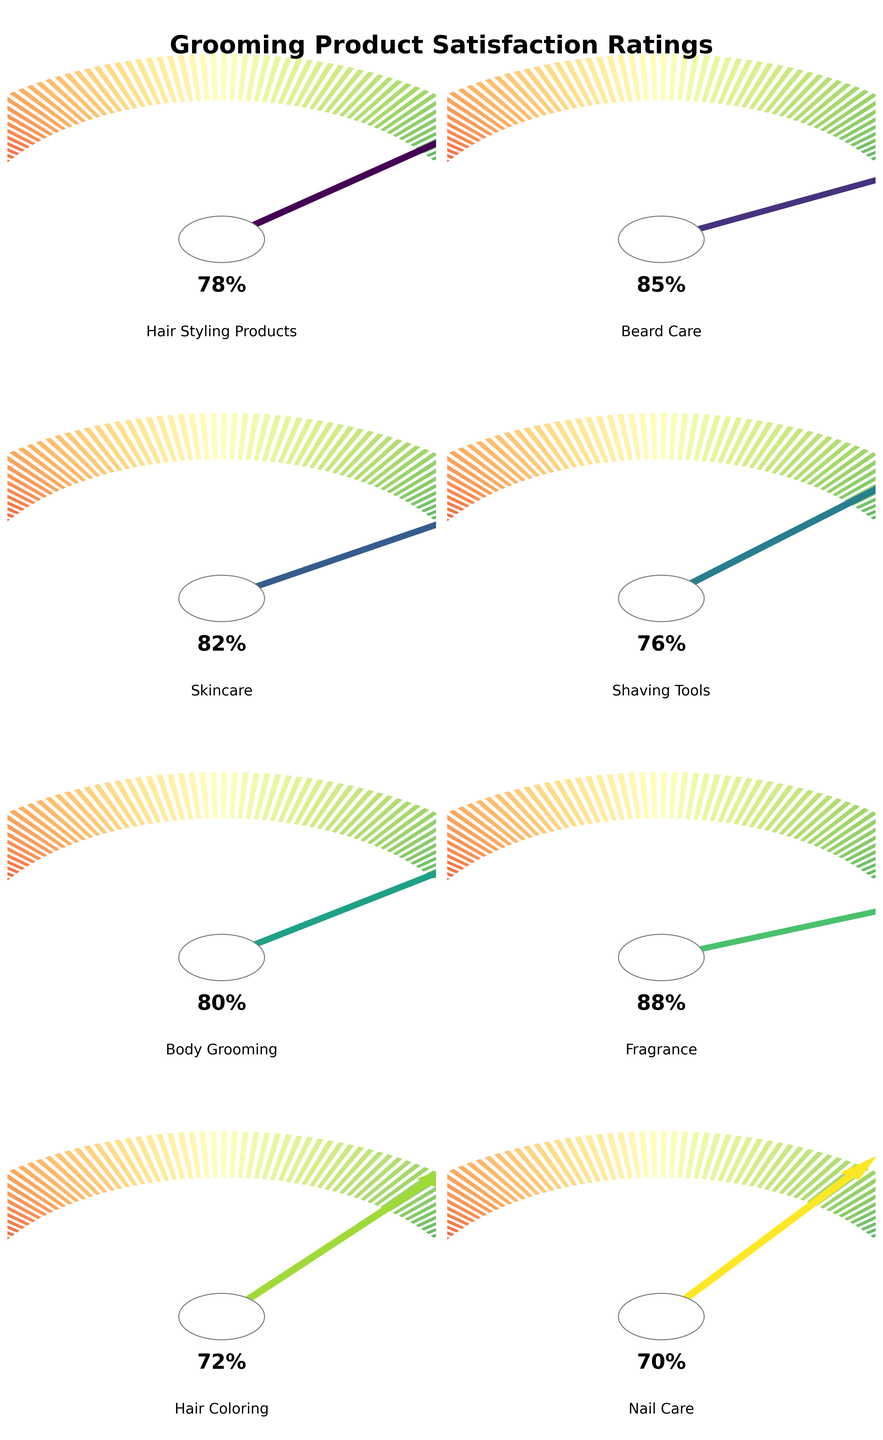What's the title of the figure? The title is given at the top of the figure in bold and large font. It reads "Grooming Product Satisfaction Ratings" as indicated in the plot generation code.
Answer: Grooming Product Satisfaction Ratings How many product categories are compared in the figure? By counting the number of gauge charts in the figure and referring to the provided data, we can see there are 8 product categories.
Answer: 8 Which grooming product category has the highest satisfaction rating? By looking at all the gauge charts and checking the satisfaction percentages shown in the middle of each chart, we see that Fragrance has the highest satisfaction rating with 88%.
Answer: Fragrance Compare the satisfaction ratings of Hair Coloring and Beard Care. Which one is higher? Checking the gauge charts for Hair Coloring and Beard Care, Hair Coloring has a satisfaction rating of 72% while Beard Care has a satisfaction rating of 85%. Therefore, Beard Care is higher.
Answer: Beard Care What is the average satisfaction rating for these grooming product categories? To find the average satisfaction rating, sum all the ratings: 78 + 85 + 82 + 76 + 80 + 88 + 72 + 70 = 631. Then, divide by the number of categories: 631 / 8 = 78.875.
Answer: 78.875 Which product category has a satisfaction rating closest to 80%? Looking through all the gauge charts, Body Grooming has a satisfaction rating of 80%, which is exactly 80%.
Answer: Body Grooming What's the difference in satisfaction ratings between the highest and lowest rated categories? The highest rating (Fragrance) is 88% and the lowest rating (Nail Care) is 70%. The difference is 88 - 70 = 18.
Answer: 18 Which product category has a lower satisfaction rating: Skincare or Shaving Tools? Checking the satisfaction ratings, Skincare is 82% and Shaving Tools is 76%. Therefore, Shaving Tools has a lower satisfaction rating.
Answer: Shaving Tools How many categories have a satisfaction rating of 80% or more? By examining each gauge chart and noting the ratings, we find that Hair Styling Products (78%), Beard Care (85%), Skincare (82%), Body Grooming (80%), and Fragrance (88%) meet this criterion, totaling 5 categories.
Answer: 5 What is the median satisfaction rating of these grooming product categories? To determine the median satisfaction rating, list all ratings in order: 70, 72, 76, 78, 80, 82, 85, 88. Since there are 8 data points, the median is the average of the 4th and 5th values: (78 + 80) / 2 = 79.
Answer: 79 